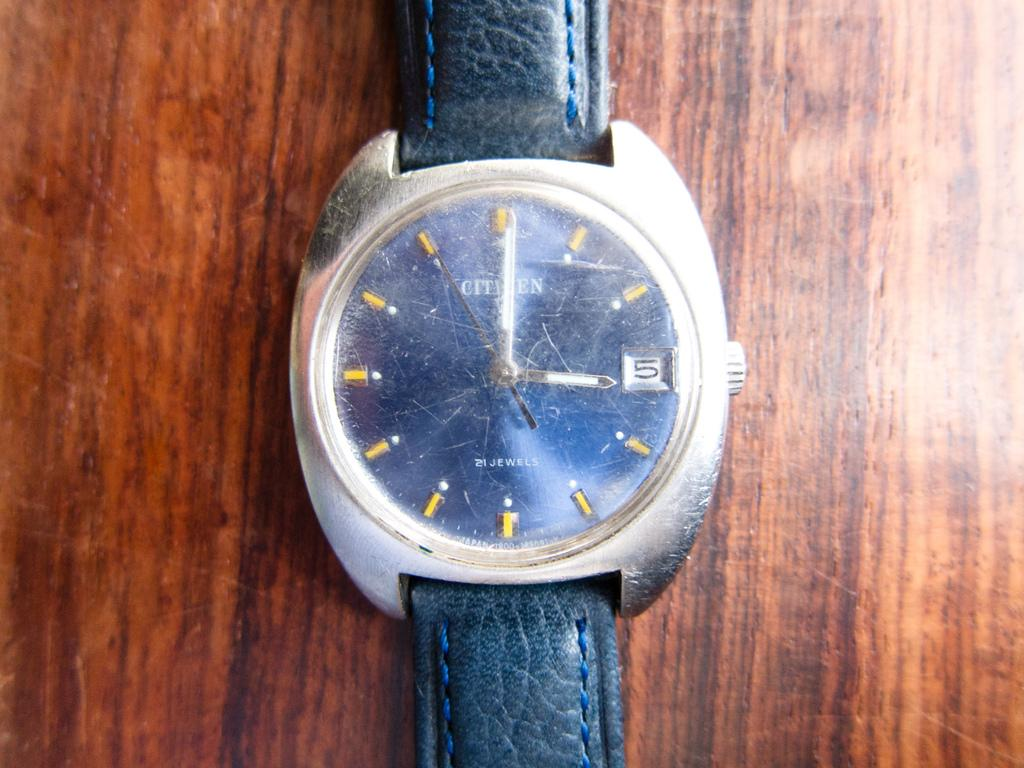<image>
Offer a succinct explanation of the picture presented. A Citizens watch with cracked glass over the clock piece. 